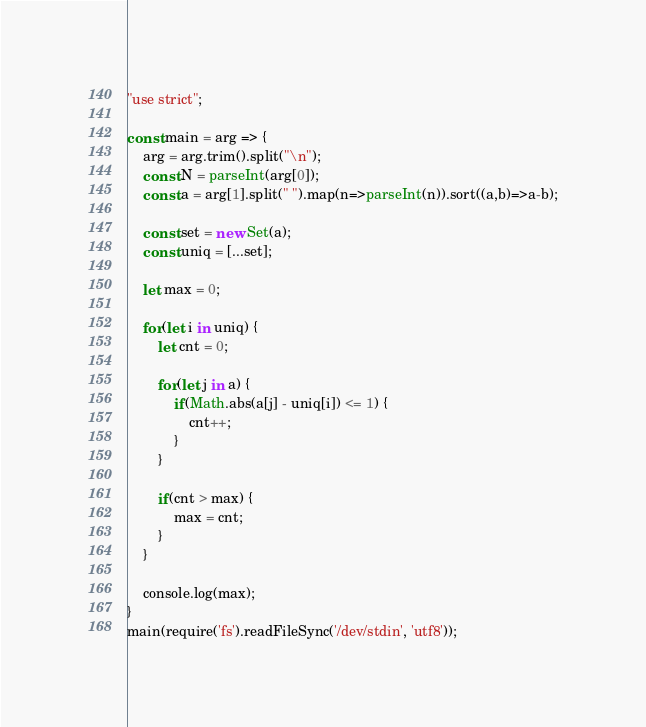Convert code to text. <code><loc_0><loc_0><loc_500><loc_500><_JavaScript_>"use strict";
    
const main = arg => {
    arg = arg.trim().split("\n");
    const N = parseInt(arg[0]);
    const a = arg[1].split(" ").map(n=>parseInt(n)).sort((a,b)=>a-b);
    
    const set = new Set(a);
    const uniq = [...set];
    
    let max = 0;
    
    for(let i in uniq) {
        let cnt = 0;
        
        for(let j in a) {
            if(Math.abs(a[j] - uniq[i]) <= 1) {
                cnt++;
            }
        }
        
        if(cnt > max) {
            max = cnt;
        }
    }
    
    console.log(max);
}
main(require('fs').readFileSync('/dev/stdin', 'utf8'));</code> 